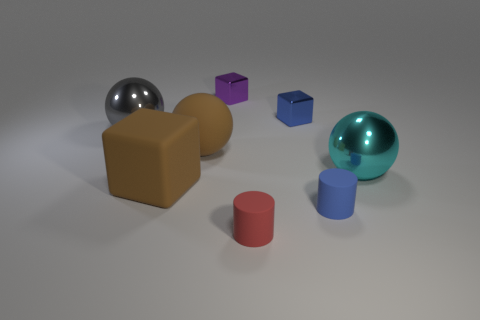How many other objects are the same material as the cyan sphere?
Your answer should be very brief. 3. There is a thing to the left of the rubber cube; does it have the same shape as the big cyan thing?
Provide a short and direct response. Yes. Is there a small cyan cylinder?
Your answer should be very brief. No. Is there anything else that is the same shape as the blue metallic object?
Make the answer very short. Yes. Are there more cyan objects that are right of the cyan metallic thing than small blue rubber cylinders?
Make the answer very short. No. Are there any rubber cylinders left of the tiny blue metallic block?
Give a very brief answer. Yes. Do the red matte thing and the blue matte object have the same size?
Your answer should be very brief. Yes. What is the size of the other rubber object that is the same shape as the red rubber object?
Your answer should be very brief. Small. What is the ball that is on the right side of the cube that is to the right of the red rubber cylinder made of?
Provide a short and direct response. Metal. Is the cyan metal thing the same shape as the small red rubber object?
Your answer should be very brief. No. 